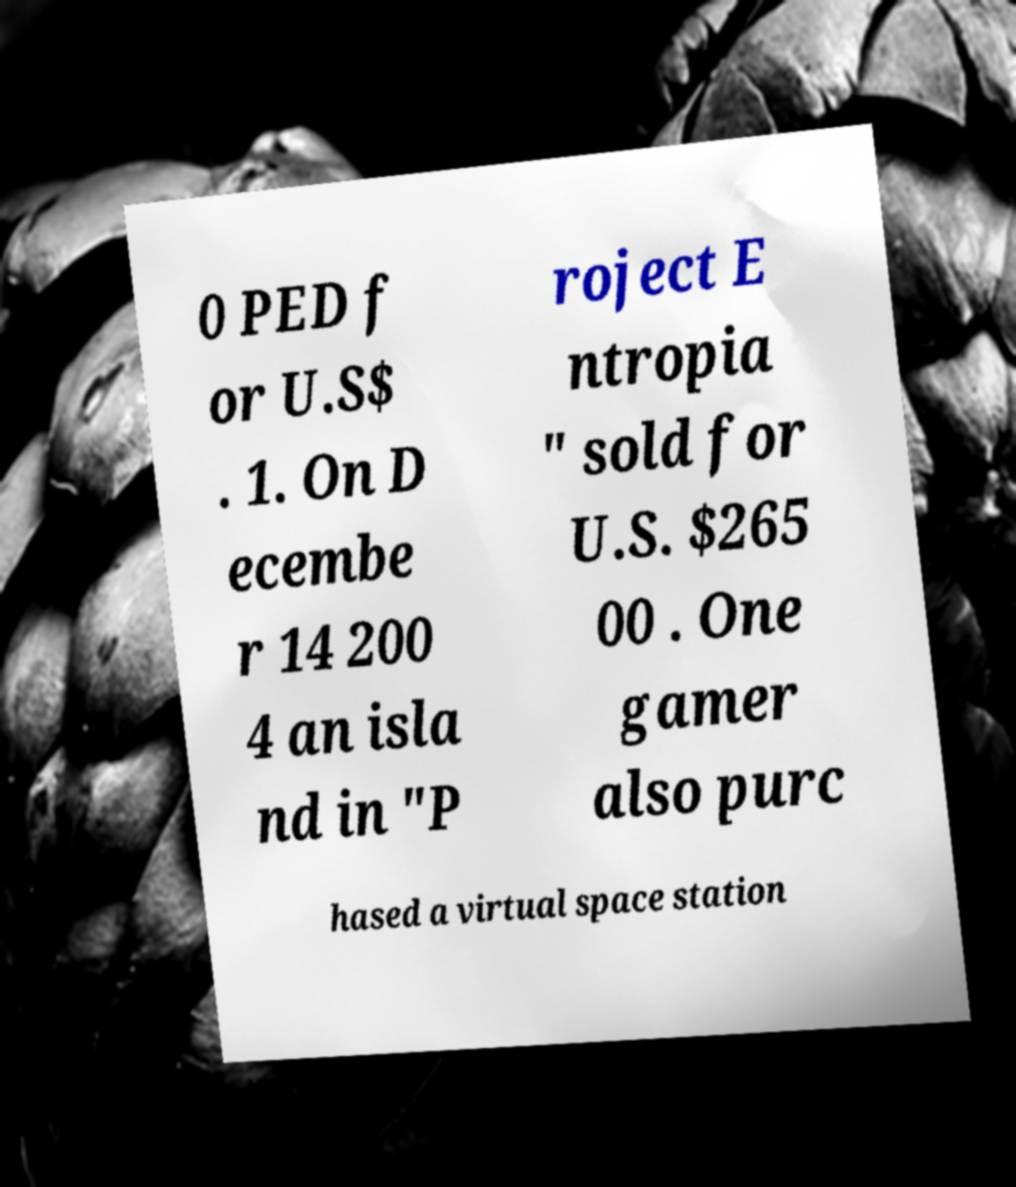Can you accurately transcribe the text from the provided image for me? 0 PED f or U.S$ . 1. On D ecembe r 14 200 4 an isla nd in "P roject E ntropia " sold for U.S. $265 00 . One gamer also purc hased a virtual space station 